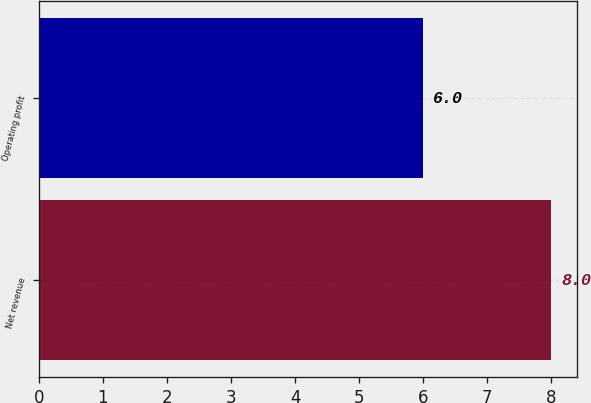Convert chart to OTSL. <chart><loc_0><loc_0><loc_500><loc_500><bar_chart><fcel>Net revenue<fcel>Operating profit<nl><fcel>8<fcel>6<nl></chart> 